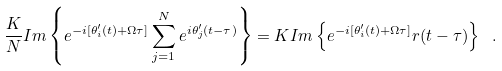<formula> <loc_0><loc_0><loc_500><loc_500>\frac { K } { N } I m \left \{ e ^ { - i [ \theta ^ { \prime } _ { i } ( t ) + \Omega \tau ] } \sum ^ { N } _ { j = 1 } e ^ { i \theta ^ { \prime } _ { j } ( t - \tau ) } \right \} = K I m \left \{ e ^ { - i [ \theta ^ { \prime } _ { i } ( t ) + \Omega \tau ] } r ( t - \tau ) \right \} \ .</formula> 